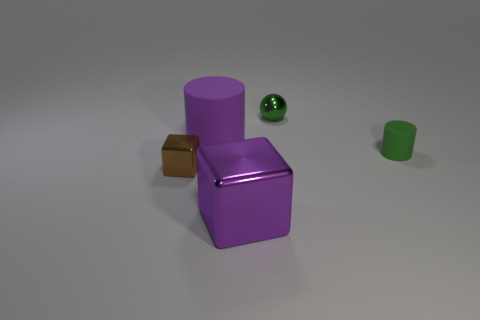What color is the other tiny metallic object that is the same shape as the purple shiny object?
Keep it short and to the point. Brown. There is a thing that is both behind the big purple metal block and in front of the green rubber thing; what material is it?
Offer a very short reply. Metal. Does the rubber cylinder left of the green metal thing have the same size as the small matte object?
Ensure brevity in your answer.  No. What is the small green cylinder made of?
Your answer should be very brief. Rubber. There is a cylinder to the right of the green ball; what is its color?
Make the answer very short. Green. How many large things are either purple things or green balls?
Provide a succinct answer. 2. Does the rubber cylinder left of the tiny ball have the same color as the big object in front of the green matte cylinder?
Your response must be concise. Yes. How many other objects are there of the same color as the large matte thing?
Your answer should be very brief. 1. How many brown objects are shiny objects or small cylinders?
Your answer should be compact. 1. There is a large purple metallic thing; does it have the same shape as the green object behind the green matte cylinder?
Provide a succinct answer. No. 